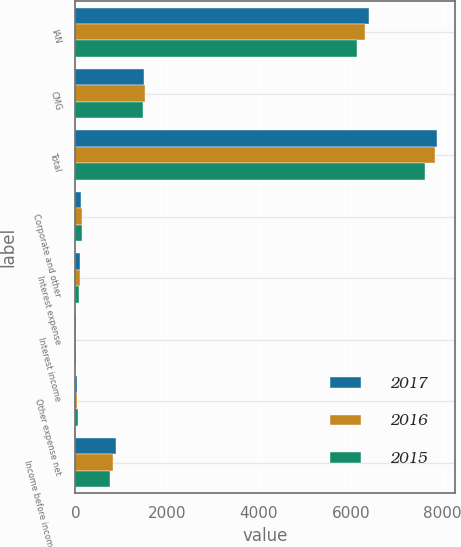Convert chart to OTSL. <chart><loc_0><loc_0><loc_500><loc_500><stacked_bar_chart><ecel><fcel>IAN<fcel>CMG<fcel>Total<fcel>Corporate and other<fcel>Interest expense<fcel>Interest income<fcel>Other expense net<fcel>Income before income taxes<nl><fcel>2017<fcel>6397.3<fcel>1485.1<fcel>7882.4<fcel>126.6<fcel>90.8<fcel>19.4<fcel>26.2<fcel>876<nl><fcel>2016<fcel>6319.4<fcel>1527.2<fcel>7846.6<fcel>147.2<fcel>90.6<fcel>20.1<fcel>40.3<fcel>830.2<nl><fcel>2015<fcel>6145.4<fcel>1468.4<fcel>7613.8<fcel>141.8<fcel>85.8<fcel>22.8<fcel>49.6<fcel>762.2<nl></chart> 